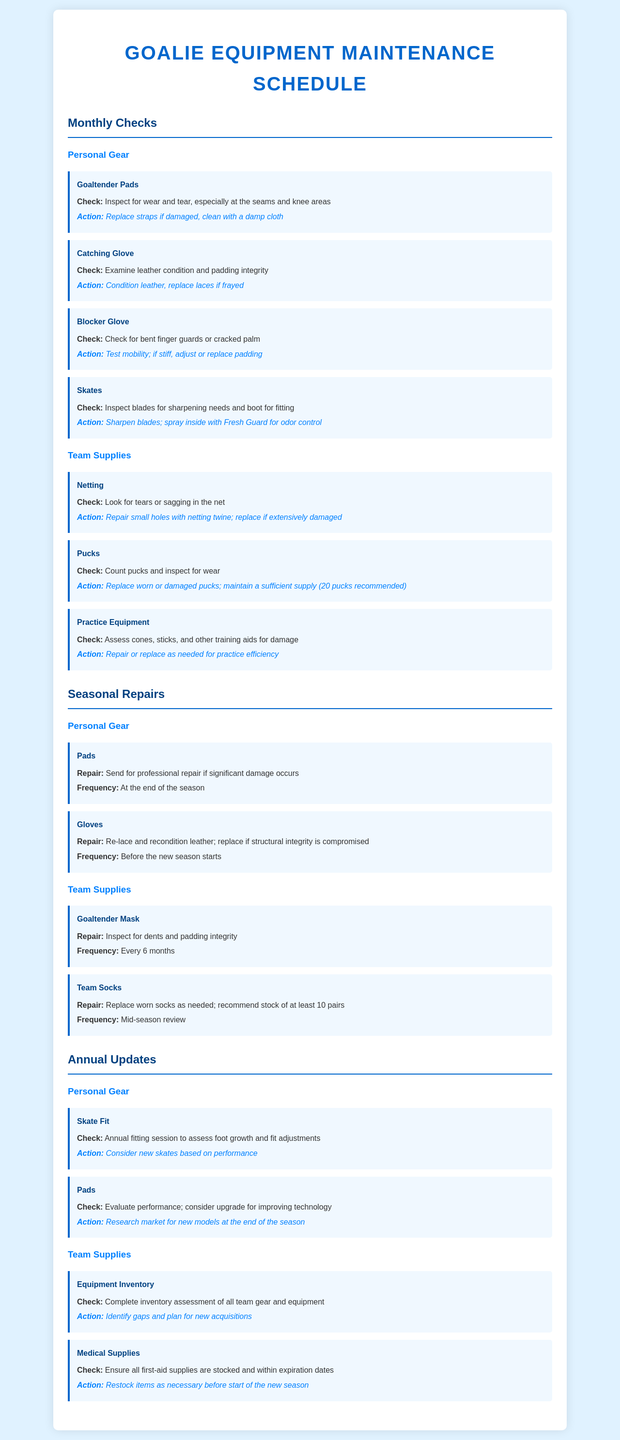What is inspected in goaltender pads? The document states that wear and tear, especially at the seams and knee areas, should be inspected.
Answer: Wear and tear How often should the goaltender mask be repaired? It mentions that the repair frequency is every 6 months.
Answer: Every 6 months What action is recommended for the catching glove? The document suggests conditioning the leather and replacing laces if frayed.
Answer: Condition leather, replace laces How many pucks are recommended to maintain? The document recommends maintaining a sufficient supply of 20 pucks.
Answer: 20 pucks When should skate fit be checked? The schedule indicates that skate fit should be checked in an annual fitting session.
Answer: Annual fitting session What should be done if pads have significant damage? It states that pads should be sent for professional repair if significant damage occurs.
Answer: Send for professional repair What is the action for medical supplies? The document says to restock items as necessary before the start of the new season.
Answer: Restock items What is recommended if finger guards on the blocker glove are bent? It is recommended to test mobility and if stiff, adjust or replace padding.
Answer: Adjust or replace padding 